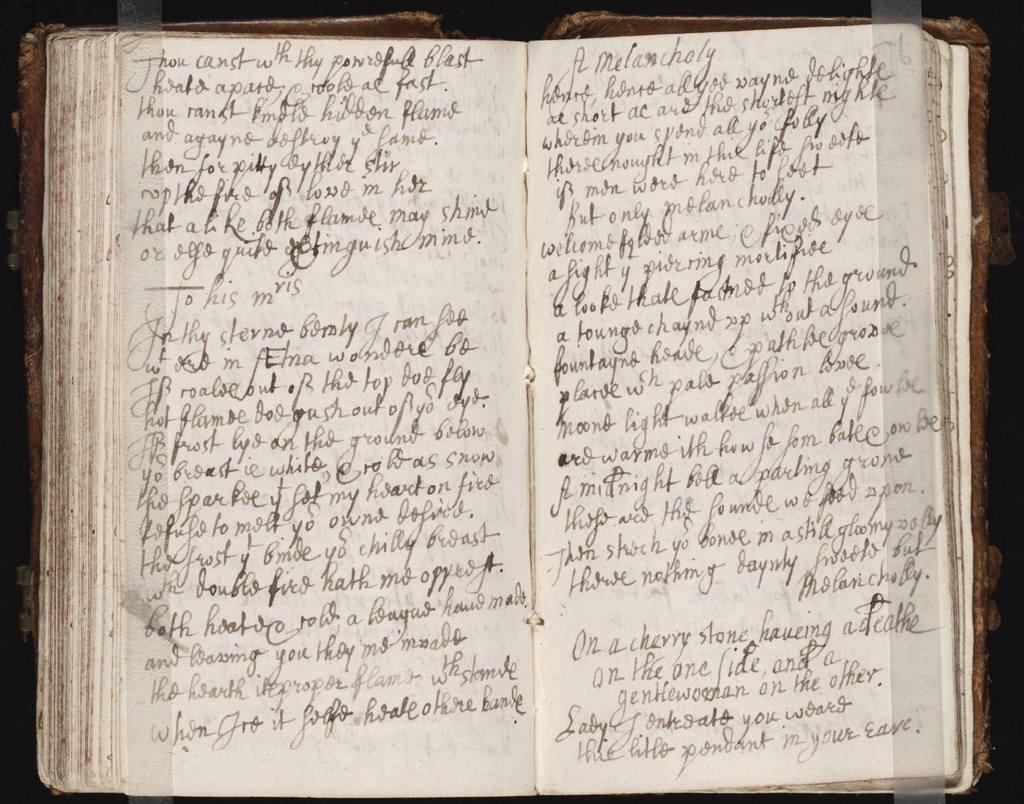Provide a one-sentence caption for the provided image. Opened pages from an illegibly handwritten journal from the time when "thou' is used. 